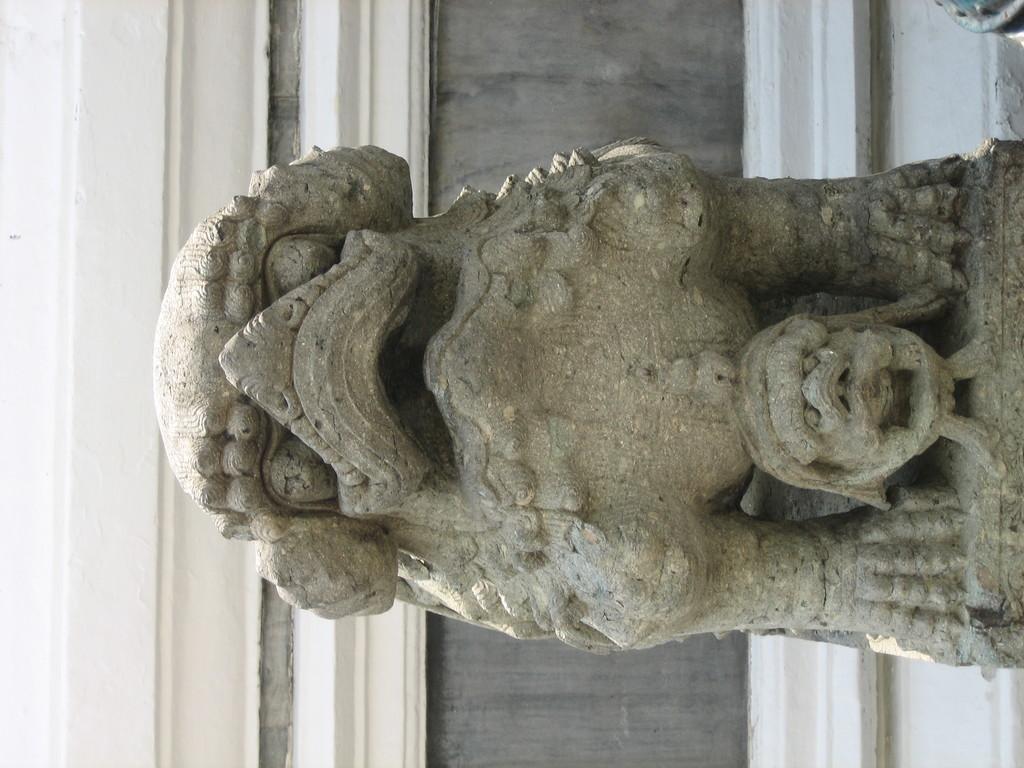Could you give a brief overview of what you see in this image? In this image there is a sculptor, the background of the image there is a wall, there is an object truncated towards the top of the image. 